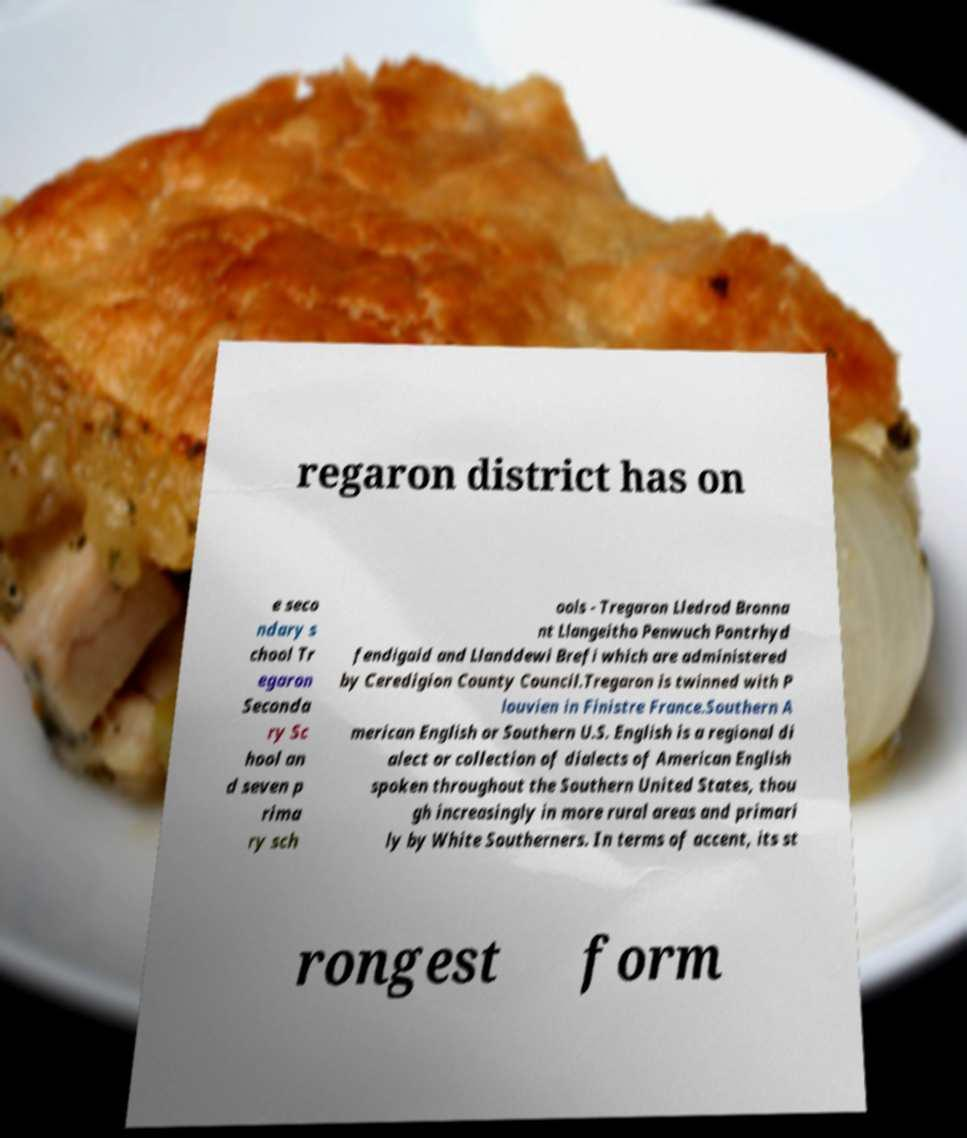Can you read and provide the text displayed in the image?This photo seems to have some interesting text. Can you extract and type it out for me? regaron district has on e seco ndary s chool Tr egaron Seconda ry Sc hool an d seven p rima ry sch ools - Tregaron Lledrod Bronna nt Llangeitho Penwuch Pontrhyd fendigaid and Llanddewi Brefi which are administered by Ceredigion County Council.Tregaron is twinned with P louvien in Finistre France.Southern A merican English or Southern U.S. English is a regional di alect or collection of dialects of American English spoken throughout the Southern United States, thou gh increasingly in more rural areas and primari ly by White Southerners. In terms of accent, its st rongest form 